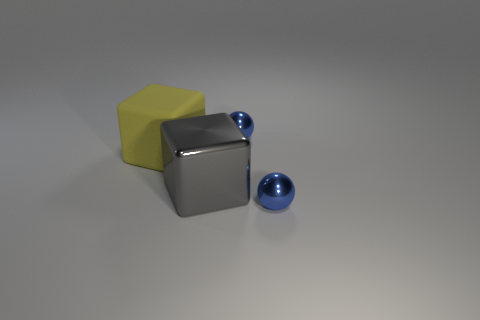What can you infer about the materials used for these objects? Based on their appearance, the objects seem to be composed of different materials. The central cube's reflective property and sharp edges suggest a metallic material, possibly stainless steel or polished aluminum. The left block's yellow color and matte texture resemble rubber. The spheres share the reflective quality of the central cube, implying a material like polished metal, or they could also be glass due to their transparency and clear reflections. 